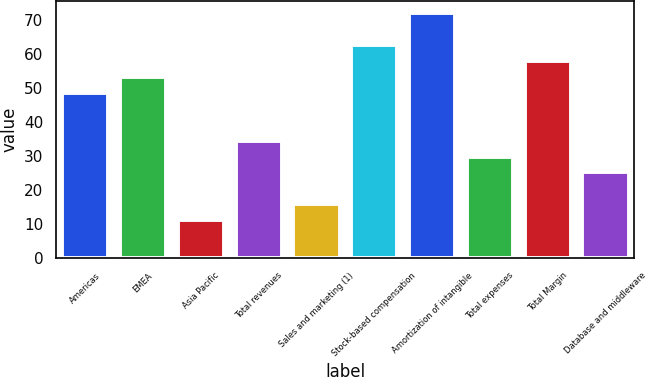Convert chart to OTSL. <chart><loc_0><loc_0><loc_500><loc_500><bar_chart><fcel>Americas<fcel>EMEA<fcel>Asia Pacific<fcel>Total revenues<fcel>Sales and marketing (1)<fcel>Stock-based compensation<fcel>Amortization of intangible<fcel>Total expenses<fcel>Total Margin<fcel>Database and middleware<nl><fcel>48.6<fcel>53.3<fcel>11<fcel>34.5<fcel>15.7<fcel>62.7<fcel>72.1<fcel>29.8<fcel>58<fcel>25.1<nl></chart> 